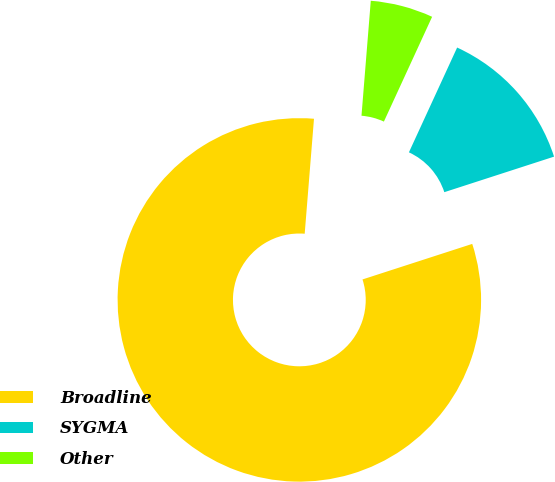Convert chart to OTSL. <chart><loc_0><loc_0><loc_500><loc_500><pie_chart><fcel>Broadline<fcel>SYGMA<fcel>Other<nl><fcel>81.27%<fcel>13.15%<fcel>5.58%<nl></chart> 